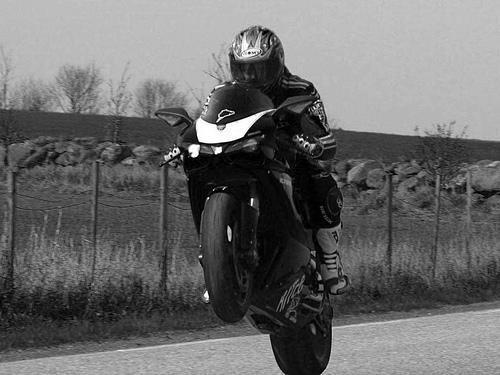How many people are there?
Give a very brief answer. 1. 